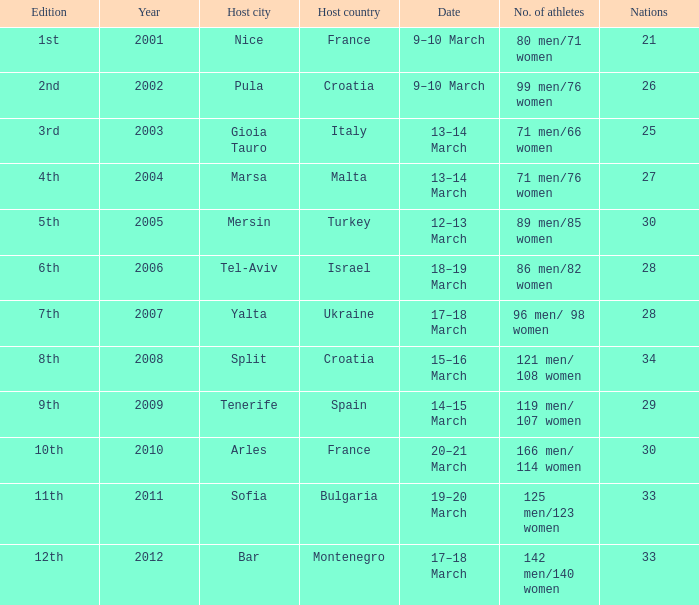For the 7th edition, what was the total number of athletes? 96 men/ 98 women. 